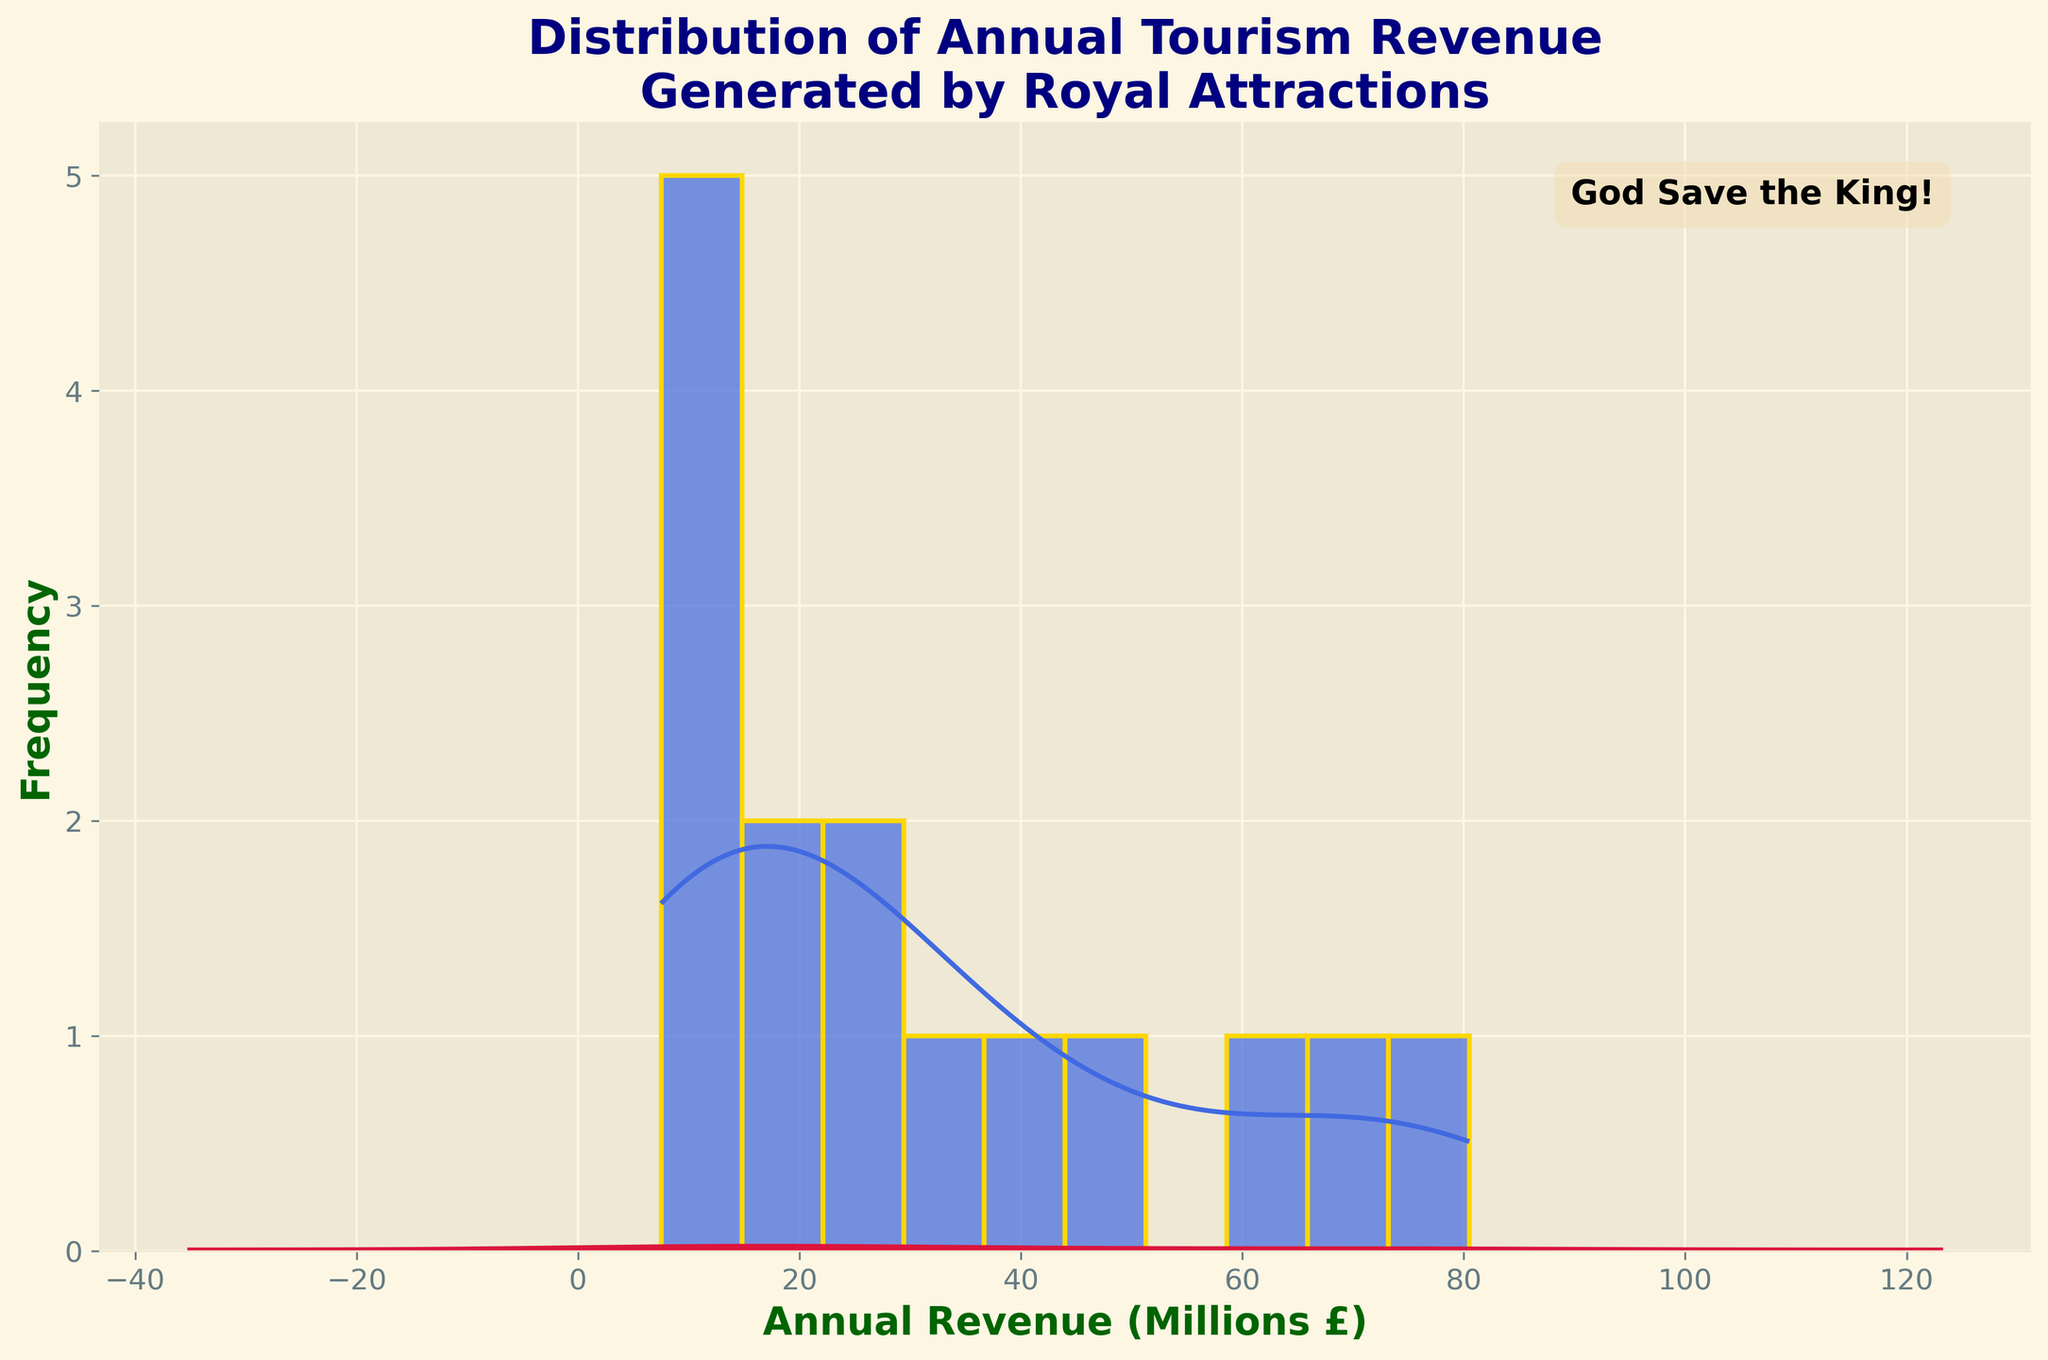What is the title of the figure? The title is displayed prominently at the top of the figure. It reads: "Distribution of Annual Tourism Revenue Generated by Royal Attractions".
Answer: Distribution of Annual Tourism Revenue Generated by Royal Attractions What is the x-axis labeled as? The x-axis label is noted at the bottom of the histogram. It reads: "Annual Revenue (Millions £)".
Answer: Annual Revenue (Millions £) What is the color of the histogram bars? The color of the histogram bars can be visually identified as royal blue with a gold edge.
Answer: Royal blue Which attraction has the highest annual revenue? The KDE peak indicates the highest grouping around the value corresponding to Buckingham Palace, which is £80.5 million.
Answer: Buckingham Palace Approximately, what is the most frequent range of annual revenue? The histogram bars with the highest height indicate the most frequent range. The KDE curve's highest point aligns with the range of around £30 to £40 million.
Answer: £30 to £40 million What is the average annual revenue generated by the royal attractions? Sum up all the attractions’ annual revenues and divide by the number of attractions. The sum is 493 (80.5 + 65.2 + 72.8 + 45.6 + 38.9 + 30.1 + 25.7 + 22.3 + 18.5 + 15.9 + 12.4 + 10.8 + 9.6 + 8.2 + 7.5). There are 15 attractions. So, the average is 493 / 15 = 32.87 million pounds.
Answer: £32.87 million How many royal attractions have an annual revenue greater than £50 million? The bars to the right of the £50 million mark can be counted. The relevant attractions are Buckingham Palace, Windsor Castle, and Tower of London.
Answer: 3 Which attraction's revenue is closest to the average annual revenue of the attractions? The average annual revenue is £32.87 million. Comparing this to individual attraction revenues, Holyrood Palace at £30.1 million is closest to the average.
Answer: Holyrood Palace How does the appearance of the KDE (density curve) help in understanding the distribution better than the histogram alone? The KDE curve smooths out the frequencies, providing a continuous estimate of the distribution shape, revealing the general tendencies, such as the main peaks around the center of distribution without the discontinuity of histogram bins.
Answer: It provides a continuous view of distribution peaks and helps in understanding general tendencies What is the lowest annual revenue, and which attraction does it belong to? The leftmost bar on the histogram corresponds to the lowest annual revenue. Osborne House at £7.5 million is the lowest.
Answer: Hillsborough Castle at £7.5 million 